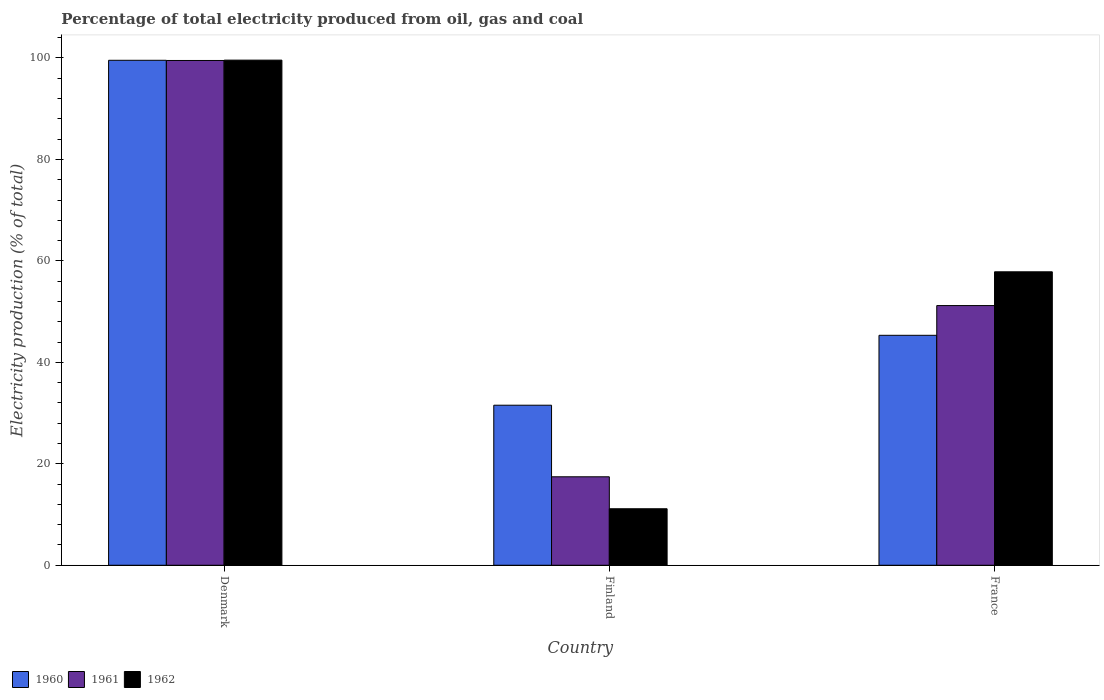How many different coloured bars are there?
Give a very brief answer. 3. How many groups of bars are there?
Ensure brevity in your answer.  3. Are the number of bars per tick equal to the number of legend labels?
Offer a very short reply. Yes. Are the number of bars on each tick of the X-axis equal?
Your answer should be very brief. Yes. In how many cases, is the number of bars for a given country not equal to the number of legend labels?
Provide a short and direct response. 0. What is the electricity production in in 1961 in Finland?
Offer a terse response. 17.44. Across all countries, what is the maximum electricity production in in 1960?
Your answer should be compact. 99.55. Across all countries, what is the minimum electricity production in in 1960?
Provide a short and direct response. 31.55. In which country was the electricity production in in 1961 maximum?
Ensure brevity in your answer.  Denmark. What is the total electricity production in in 1962 in the graph?
Make the answer very short. 168.57. What is the difference between the electricity production in in 1962 in Finland and that in France?
Give a very brief answer. -46.71. What is the difference between the electricity production in in 1962 in France and the electricity production in in 1960 in Finland?
Ensure brevity in your answer.  26.3. What is the average electricity production in in 1960 per country?
Your answer should be compact. 58.81. What is the difference between the electricity production in of/in 1960 and electricity production in of/in 1961 in Denmark?
Your answer should be compact. 0.04. In how many countries, is the electricity production in in 1961 greater than 84 %?
Provide a short and direct response. 1. What is the ratio of the electricity production in in 1960 in Denmark to that in Finland?
Provide a succinct answer. 3.16. What is the difference between the highest and the second highest electricity production in in 1960?
Provide a short and direct response. 54.22. What is the difference between the highest and the lowest electricity production in in 1962?
Offer a very short reply. 88.44. In how many countries, is the electricity production in in 1960 greater than the average electricity production in in 1960 taken over all countries?
Provide a succinct answer. 1. Is the sum of the electricity production in in 1960 in Denmark and France greater than the maximum electricity production in in 1961 across all countries?
Offer a terse response. Yes. What does the 2nd bar from the right in France represents?
Your answer should be very brief. 1961. Is it the case that in every country, the sum of the electricity production in in 1962 and electricity production in in 1960 is greater than the electricity production in in 1961?
Your answer should be compact. Yes. How many bars are there?
Ensure brevity in your answer.  9. Are all the bars in the graph horizontal?
Ensure brevity in your answer.  No. Does the graph contain any zero values?
Keep it short and to the point. No. How are the legend labels stacked?
Keep it short and to the point. Horizontal. What is the title of the graph?
Provide a short and direct response. Percentage of total electricity produced from oil, gas and coal. What is the label or title of the Y-axis?
Provide a succinct answer. Electricity production (% of total). What is the Electricity production (% of total) of 1960 in Denmark?
Provide a succinct answer. 99.55. What is the Electricity production (% of total) of 1961 in Denmark?
Offer a terse response. 99.51. What is the Electricity production (% of total) in 1962 in Denmark?
Your response must be concise. 99.58. What is the Electricity production (% of total) in 1960 in Finland?
Keep it short and to the point. 31.55. What is the Electricity production (% of total) of 1961 in Finland?
Your answer should be compact. 17.44. What is the Electricity production (% of total) in 1962 in Finland?
Offer a very short reply. 11.14. What is the Electricity production (% of total) of 1960 in France?
Keep it short and to the point. 45.33. What is the Electricity production (% of total) in 1961 in France?
Offer a very short reply. 51.19. What is the Electricity production (% of total) of 1962 in France?
Ensure brevity in your answer.  57.85. Across all countries, what is the maximum Electricity production (% of total) of 1960?
Offer a terse response. 99.55. Across all countries, what is the maximum Electricity production (% of total) in 1961?
Provide a short and direct response. 99.51. Across all countries, what is the maximum Electricity production (% of total) of 1962?
Your answer should be compact. 99.58. Across all countries, what is the minimum Electricity production (% of total) in 1960?
Your response must be concise. 31.55. Across all countries, what is the minimum Electricity production (% of total) of 1961?
Provide a succinct answer. 17.44. Across all countries, what is the minimum Electricity production (% of total) of 1962?
Provide a succinct answer. 11.14. What is the total Electricity production (% of total) in 1960 in the graph?
Offer a very short reply. 176.43. What is the total Electricity production (% of total) of 1961 in the graph?
Ensure brevity in your answer.  168.14. What is the total Electricity production (% of total) in 1962 in the graph?
Offer a terse response. 168.57. What is the difference between the Electricity production (% of total) in 1960 in Denmark and that in Finland?
Offer a terse response. 68. What is the difference between the Electricity production (% of total) of 1961 in Denmark and that in Finland?
Your response must be concise. 82.07. What is the difference between the Electricity production (% of total) in 1962 in Denmark and that in Finland?
Your answer should be compact. 88.44. What is the difference between the Electricity production (% of total) of 1960 in Denmark and that in France?
Make the answer very short. 54.22. What is the difference between the Electricity production (% of total) of 1961 in Denmark and that in France?
Make the answer very short. 48.32. What is the difference between the Electricity production (% of total) in 1962 in Denmark and that in France?
Provide a short and direct response. 41.73. What is the difference between the Electricity production (% of total) in 1960 in Finland and that in France?
Give a very brief answer. -13.78. What is the difference between the Electricity production (% of total) in 1961 in Finland and that in France?
Ensure brevity in your answer.  -33.75. What is the difference between the Electricity production (% of total) of 1962 in Finland and that in France?
Provide a succinct answer. -46.71. What is the difference between the Electricity production (% of total) in 1960 in Denmark and the Electricity production (% of total) in 1961 in Finland?
Your response must be concise. 82.11. What is the difference between the Electricity production (% of total) in 1960 in Denmark and the Electricity production (% of total) in 1962 in Finland?
Provide a short and direct response. 88.41. What is the difference between the Electricity production (% of total) in 1961 in Denmark and the Electricity production (% of total) in 1962 in Finland?
Offer a very short reply. 88.37. What is the difference between the Electricity production (% of total) of 1960 in Denmark and the Electricity production (% of total) of 1961 in France?
Your response must be concise. 48.36. What is the difference between the Electricity production (% of total) in 1960 in Denmark and the Electricity production (% of total) in 1962 in France?
Provide a short and direct response. 41.7. What is the difference between the Electricity production (% of total) of 1961 in Denmark and the Electricity production (% of total) of 1962 in France?
Make the answer very short. 41.66. What is the difference between the Electricity production (% of total) in 1960 in Finland and the Electricity production (% of total) in 1961 in France?
Keep it short and to the point. -19.64. What is the difference between the Electricity production (% of total) in 1960 in Finland and the Electricity production (% of total) in 1962 in France?
Offer a very short reply. -26.3. What is the difference between the Electricity production (% of total) of 1961 in Finland and the Electricity production (% of total) of 1962 in France?
Your answer should be compact. -40.41. What is the average Electricity production (% of total) in 1960 per country?
Provide a succinct answer. 58.81. What is the average Electricity production (% of total) of 1961 per country?
Offer a very short reply. 56.05. What is the average Electricity production (% of total) of 1962 per country?
Your answer should be compact. 56.19. What is the difference between the Electricity production (% of total) of 1960 and Electricity production (% of total) of 1961 in Denmark?
Make the answer very short. 0.04. What is the difference between the Electricity production (% of total) of 1960 and Electricity production (% of total) of 1962 in Denmark?
Offer a terse response. -0.03. What is the difference between the Electricity production (% of total) of 1961 and Electricity production (% of total) of 1962 in Denmark?
Ensure brevity in your answer.  -0.07. What is the difference between the Electricity production (% of total) of 1960 and Electricity production (% of total) of 1961 in Finland?
Ensure brevity in your answer.  14.11. What is the difference between the Electricity production (% of total) in 1960 and Electricity production (% of total) in 1962 in Finland?
Keep it short and to the point. 20.41. What is the difference between the Electricity production (% of total) of 1961 and Electricity production (% of total) of 1962 in Finland?
Ensure brevity in your answer.  6.3. What is the difference between the Electricity production (% of total) in 1960 and Electricity production (% of total) in 1961 in France?
Your answer should be very brief. -5.86. What is the difference between the Electricity production (% of total) of 1960 and Electricity production (% of total) of 1962 in France?
Your answer should be compact. -12.52. What is the difference between the Electricity production (% of total) in 1961 and Electricity production (% of total) in 1962 in France?
Your answer should be very brief. -6.66. What is the ratio of the Electricity production (% of total) in 1960 in Denmark to that in Finland?
Ensure brevity in your answer.  3.16. What is the ratio of the Electricity production (% of total) of 1961 in Denmark to that in Finland?
Your answer should be compact. 5.71. What is the ratio of the Electricity production (% of total) in 1962 in Denmark to that in Finland?
Your answer should be very brief. 8.94. What is the ratio of the Electricity production (% of total) in 1960 in Denmark to that in France?
Offer a terse response. 2.2. What is the ratio of the Electricity production (% of total) of 1961 in Denmark to that in France?
Offer a terse response. 1.94. What is the ratio of the Electricity production (% of total) in 1962 in Denmark to that in France?
Make the answer very short. 1.72. What is the ratio of the Electricity production (% of total) in 1960 in Finland to that in France?
Provide a short and direct response. 0.7. What is the ratio of the Electricity production (% of total) in 1961 in Finland to that in France?
Keep it short and to the point. 0.34. What is the ratio of the Electricity production (% of total) of 1962 in Finland to that in France?
Make the answer very short. 0.19. What is the difference between the highest and the second highest Electricity production (% of total) in 1960?
Offer a very short reply. 54.22. What is the difference between the highest and the second highest Electricity production (% of total) in 1961?
Provide a succinct answer. 48.32. What is the difference between the highest and the second highest Electricity production (% of total) in 1962?
Your answer should be compact. 41.73. What is the difference between the highest and the lowest Electricity production (% of total) of 1960?
Give a very brief answer. 68. What is the difference between the highest and the lowest Electricity production (% of total) in 1961?
Offer a terse response. 82.07. What is the difference between the highest and the lowest Electricity production (% of total) in 1962?
Your answer should be compact. 88.44. 